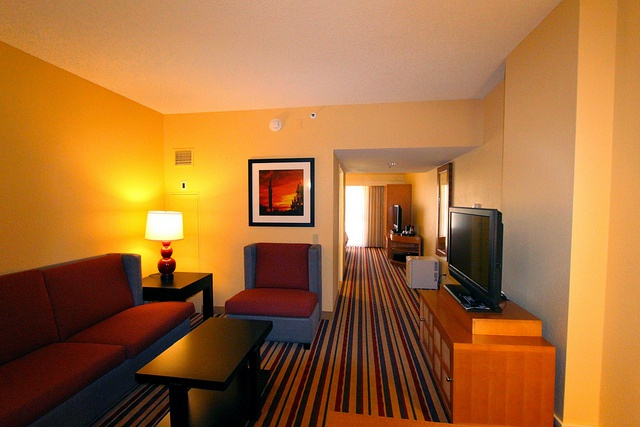Describe the objects in this image and their specific colors. I can see couch in tan, black, maroon, and brown tones, chair in tan, maroon, and black tones, tv in tan, black, and gray tones, microwave in tan, gray, and brown tones, and remote in tan, black, navy, blue, and darkblue tones in this image. 